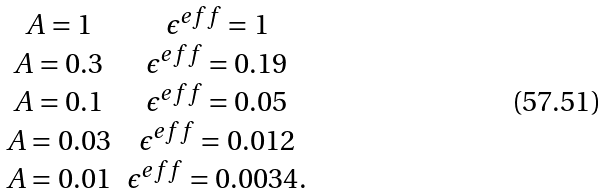Convert formula to latex. <formula><loc_0><loc_0><loc_500><loc_500>\begin{array} { c c c } A = 1 & \epsilon ^ { e f f } = 1 \\ A = 0 . 3 & \epsilon ^ { e f f } = 0 . 1 9 \\ A = 0 . 1 & \epsilon ^ { e f f } = 0 . 0 5 \\ A = 0 . 0 3 & \epsilon ^ { e f f } = 0 . 0 1 2 \\ A = 0 . 0 1 & \epsilon ^ { e f f } = 0 . 0 0 3 4 . \end{array}</formula> 